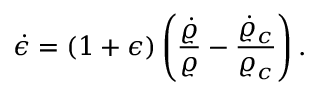<formula> <loc_0><loc_0><loc_500><loc_500>\dot { \epsilon } = ( 1 + \epsilon ) \left ( { \frac { \dot { \varrho } } { \varrho } } - { \frac { \dot { \varrho } _ { c } } { \varrho _ { c } } } \right ) .</formula> 